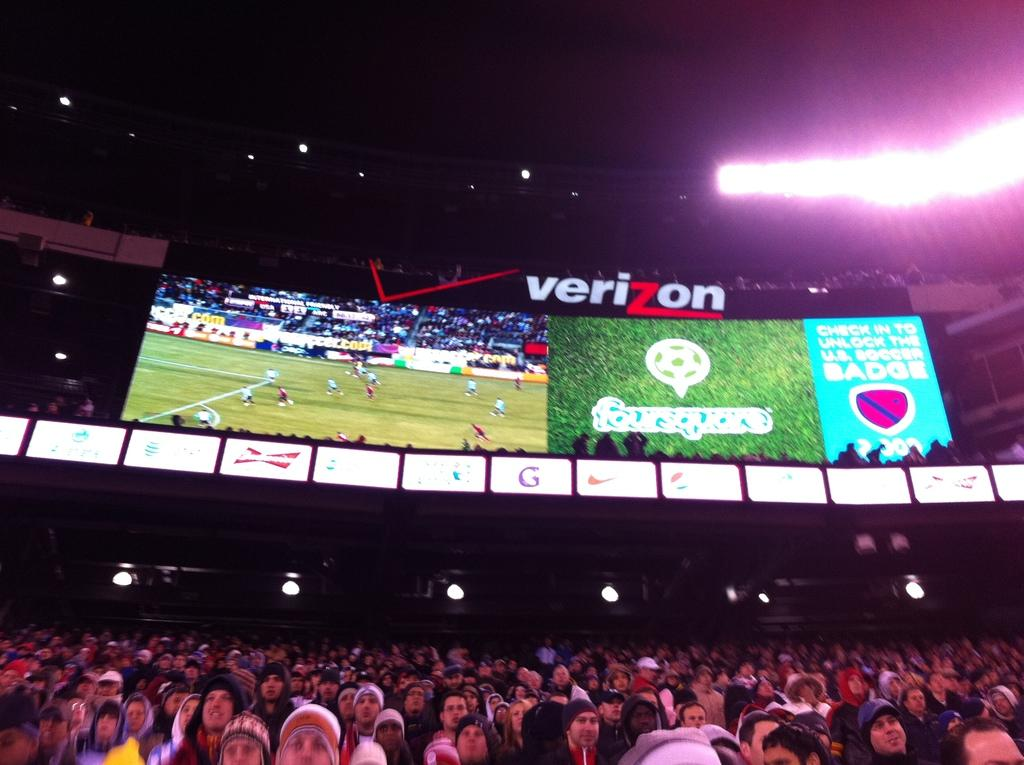<image>
Provide a brief description of the given image. The soccer stadium and a scoreboard sponsored by Verizon. 